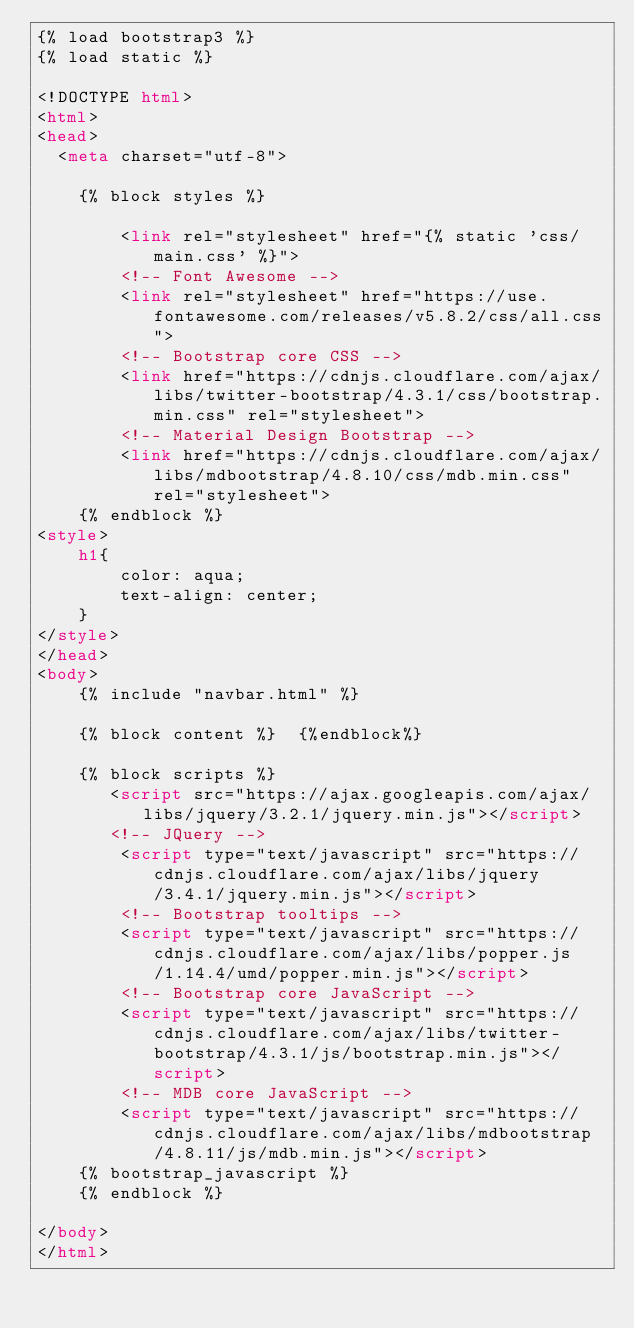<code> <loc_0><loc_0><loc_500><loc_500><_HTML_>{% load bootstrap3 %}
{% load static %}

<!DOCTYPE html>
<html>
<head>
  <meta charset="utf-8">

    {% block styles %}
       
        <link rel="stylesheet" href="{% static 'css/main.css' %}">
        <!-- Font Awesome -->
        <link rel="stylesheet" href="https://use.fontawesome.com/releases/v5.8.2/css/all.css">
        <!-- Bootstrap core CSS -->
        <link href="https://cdnjs.cloudflare.com/ajax/libs/twitter-bootstrap/4.3.1/css/bootstrap.min.css" rel="stylesheet">
        <!-- Material Design Bootstrap -->
        <link href="https://cdnjs.cloudflare.com/ajax/libs/mdbootstrap/4.8.10/css/mdb.min.css" rel="stylesheet">
    {% endblock %}
<style>
    h1{
        color: aqua;
        text-align: center;
    }
</style>
</head>
<body>
    {% include "navbar.html" %}

    {% block content %}  {%endblock%}

    {% block scripts %}
       <script src="https://ajax.googleapis.com/ajax/libs/jquery/3.2.1/jquery.min.js"></script>
       <!-- JQuery -->
        <script type="text/javascript" src="https://cdnjs.cloudflare.com/ajax/libs/jquery/3.4.1/jquery.min.js"></script>
        <!-- Bootstrap tooltips -->
        <script type="text/javascript" src="https://cdnjs.cloudflare.com/ajax/libs/popper.js/1.14.4/umd/popper.min.js"></script>
        <!-- Bootstrap core JavaScript -->
        <script type="text/javascript" src="https://cdnjs.cloudflare.com/ajax/libs/twitter-bootstrap/4.3.1/js/bootstrap.min.js"></script>
        <!-- MDB core JavaScript -->
        <script type="text/javascript" src="https://cdnjs.cloudflare.com/ajax/libs/mdbootstrap/4.8.11/js/mdb.min.js"></script>
    {% bootstrap_javascript %}
    {% endblock %}

</body>
</html></code> 